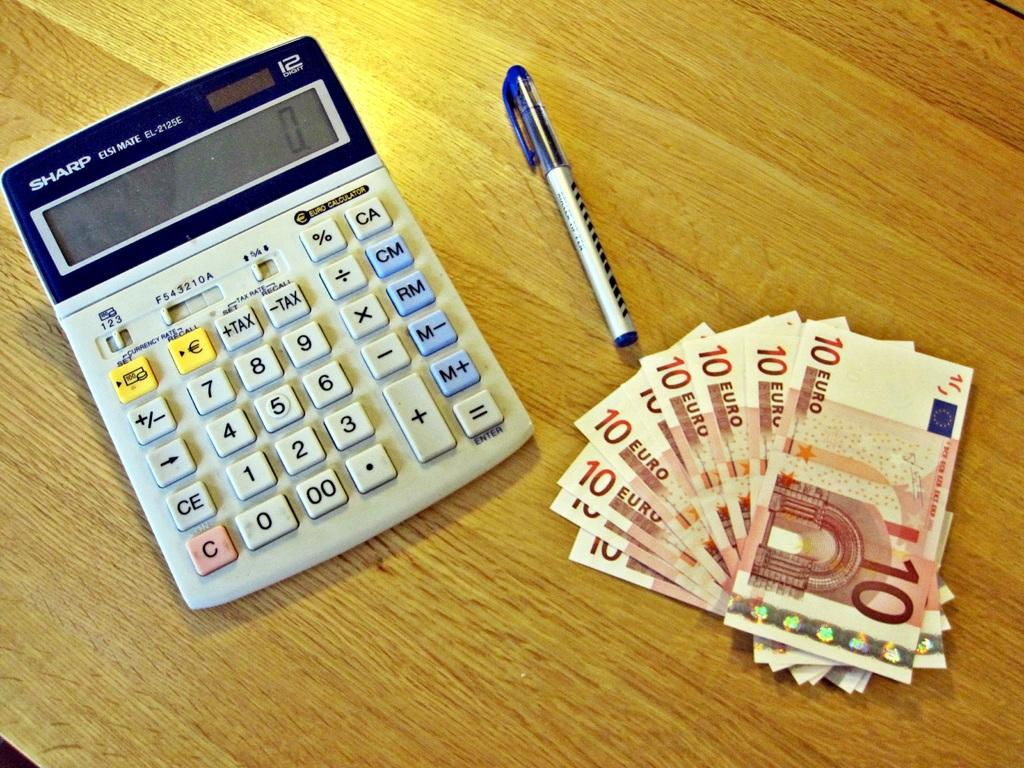<image>
Describe the image concisely. A Sharp calculator is on a desk next to a pen and some cash. 